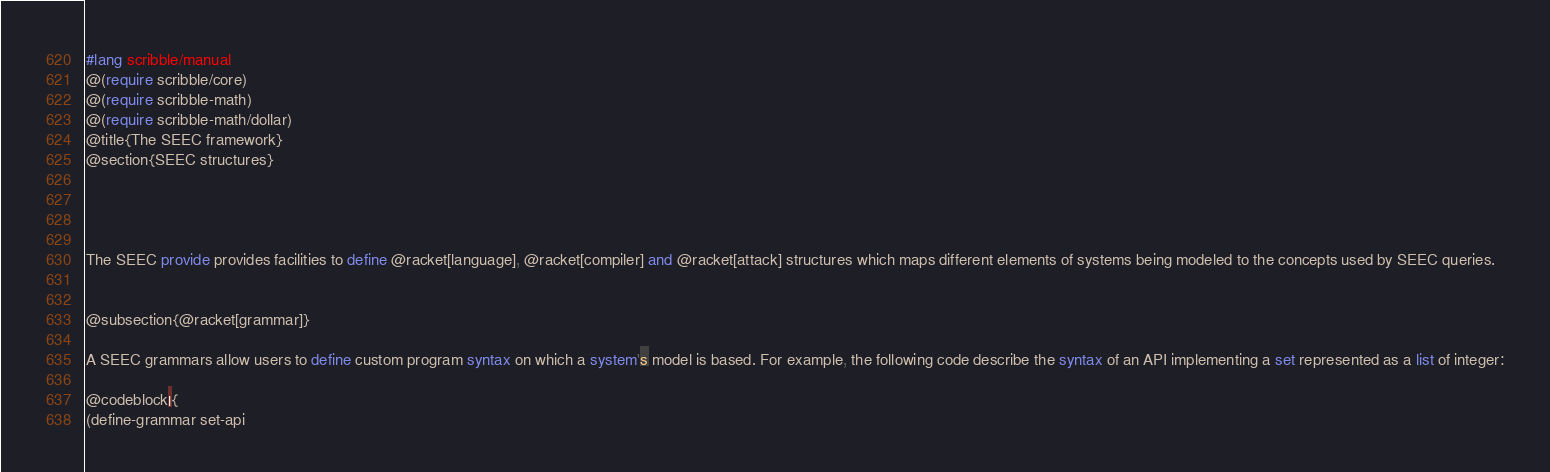Convert code to text. <code><loc_0><loc_0><loc_500><loc_500><_Racket_>#lang scribble/manual
@(require scribble/core)
@(require scribble-math)
@(require scribble-math/dollar)
@title{The SEEC framework}
@section{SEEC structures}




The SEEC provide provides facilities to define @racket[language], @racket[compiler] and @racket[attack] structures which maps different elements of systems being modeled to the concepts used by SEEC queries.


@subsection{@racket[grammar]}

A SEEC grammars allow users to define custom program syntax on which a system's model is based. For example, the following code describe the syntax of an API implementing a set represented as a list of integer:

@codeblock|{
(define-grammar set-api</code> 